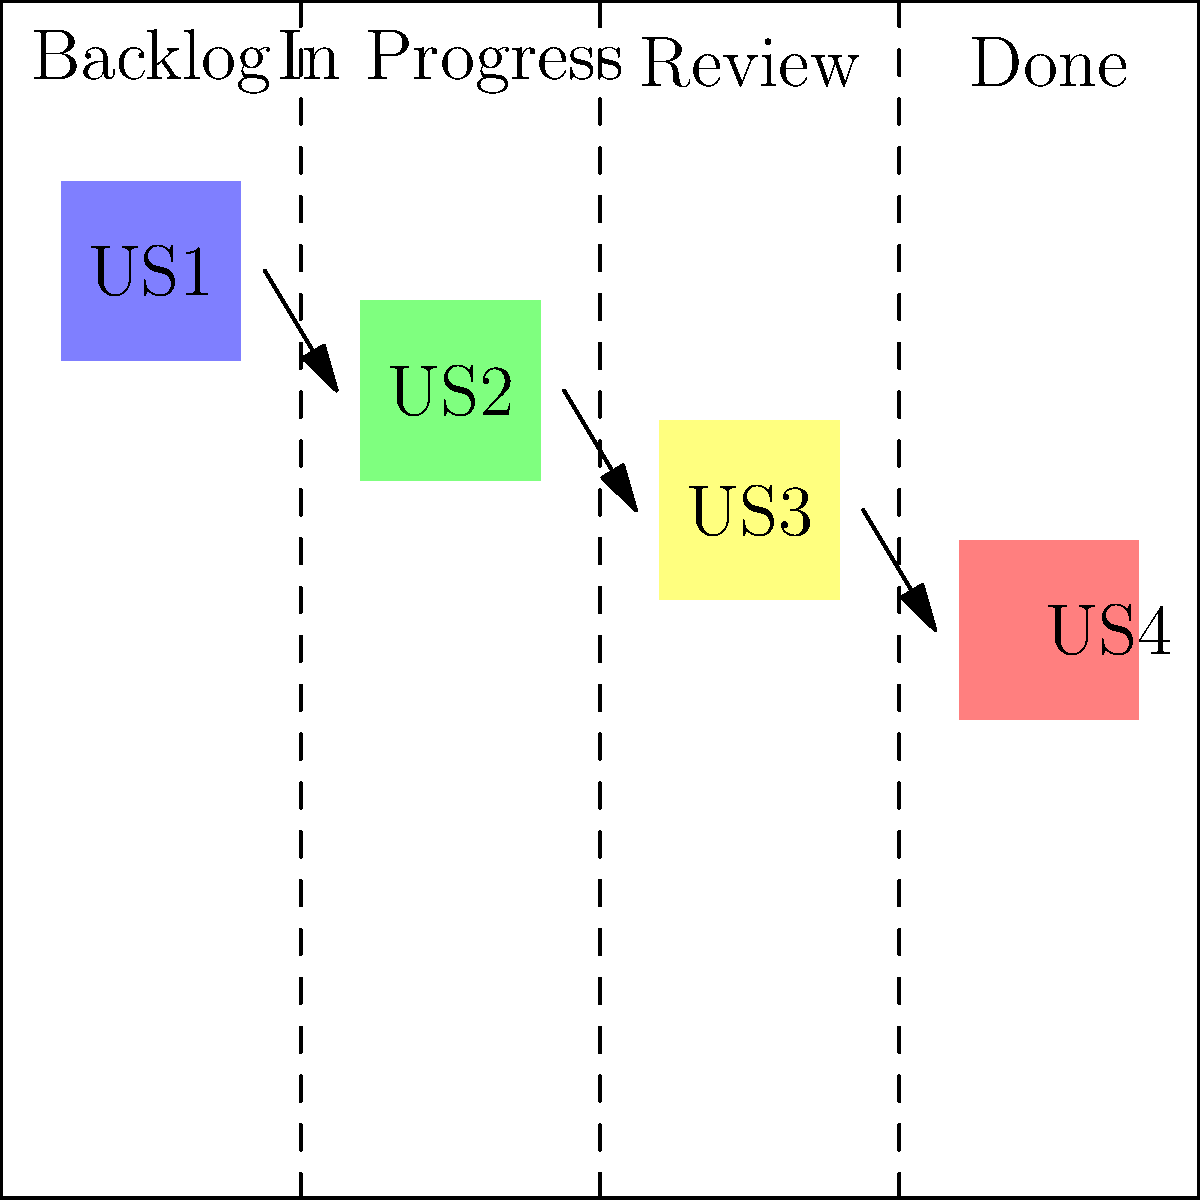In the Kanban board diagram above, which stage of the workflow has the most user stories, and what does this potentially indicate about the team's current process? To answer this question, we need to analyze the Kanban board diagram and interpret its implications:

1. The Kanban board is divided into four columns: Backlog, In Progress, Review, and Done.

2. Each column represents a stage in the workflow for user stories.

3. We can see one user story (represented by a colored box) in each column:
   - Backlog: US1 (light blue)
   - In Progress: US2 (light green)
   - Review: US3 (light yellow)
   - Done: US4 (light red)

4. Since there is an equal distribution of user stories across all stages, no single stage has the most user stories.

5. This even distribution potentially indicates:
   a) The team has a balanced workflow, with stories moving smoothly through each stage.
   b) There are no apparent bottlenecks in the process.
   c) The team may be working on multiple stories simultaneously, which could be a sign of good task management and parallel processing.

6. However, it's important to note that this is a snapshot in time, and the distribution of stories can change rapidly in an active project.

7. To gain more insights, we would need to observe the board over time and consider other factors such as the complexity of each user story and the team's velocity.
Answer: No stage has the most; even distribution indicates balanced workflow 